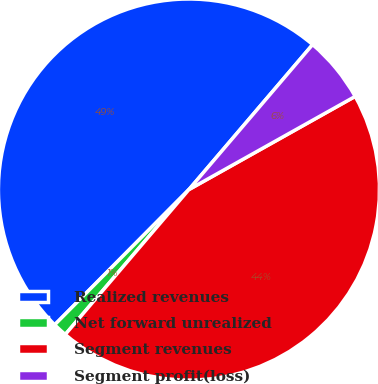<chart> <loc_0><loc_0><loc_500><loc_500><pie_chart><fcel>Realized revenues<fcel>Net forward unrealized<fcel>Segment revenues<fcel>Segment profit(loss)<nl><fcel>48.8%<fcel>1.2%<fcel>44.37%<fcel>5.63%<nl></chart> 